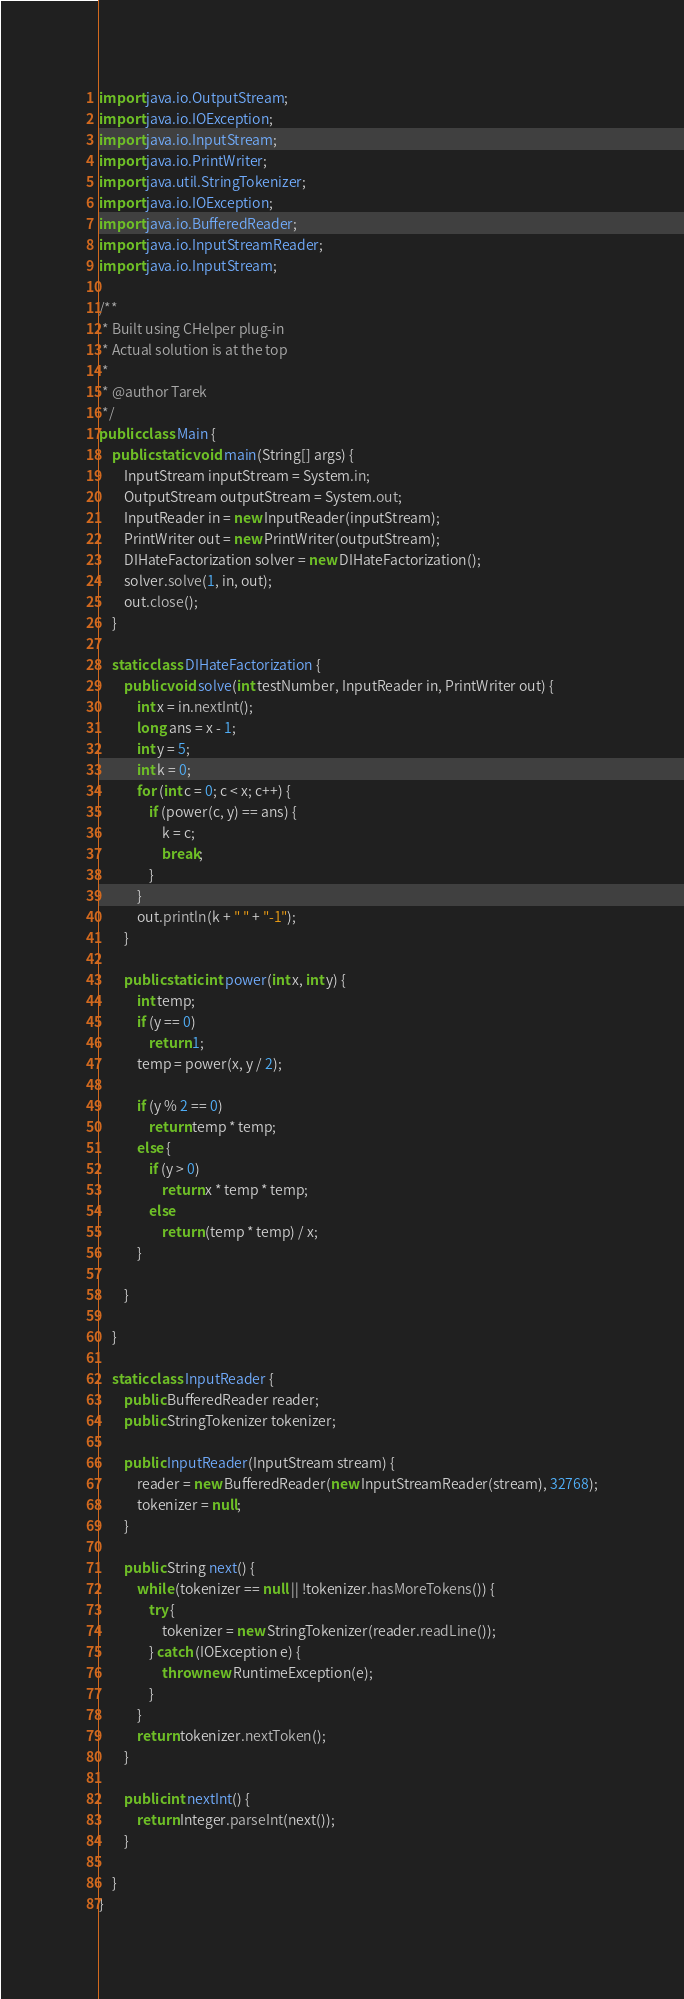<code> <loc_0><loc_0><loc_500><loc_500><_Java_>import java.io.OutputStream;
import java.io.IOException;
import java.io.InputStream;
import java.io.PrintWriter;
import java.util.StringTokenizer;
import java.io.IOException;
import java.io.BufferedReader;
import java.io.InputStreamReader;
import java.io.InputStream;

/**
 * Built using CHelper plug-in
 * Actual solution is at the top
 *
 * @author Tarek
 */
public class Main {
    public static void main(String[] args) {
        InputStream inputStream = System.in;
        OutputStream outputStream = System.out;
        InputReader in = new InputReader(inputStream);
        PrintWriter out = new PrintWriter(outputStream);
        DIHateFactorization solver = new DIHateFactorization();
        solver.solve(1, in, out);
        out.close();
    }

    static class DIHateFactorization {
        public void solve(int testNumber, InputReader in, PrintWriter out) {
            int x = in.nextInt();
            long ans = x - 1;
            int y = 5;
            int k = 0;
            for (int c = 0; c < x; c++) {
                if (power(c, y) == ans) {
                    k = c;
                    break;
                }
            }
            out.println(k + " " + "-1");
        }

        public static int power(int x, int y) {
            int temp;
            if (y == 0)
                return 1;
            temp = power(x, y / 2);

            if (y % 2 == 0)
                return temp * temp;
            else {
                if (y > 0)
                    return x * temp * temp;
                else
                    return (temp * temp) / x;
            }

        }

    }

    static class InputReader {
        public BufferedReader reader;
        public StringTokenizer tokenizer;

        public InputReader(InputStream stream) {
            reader = new BufferedReader(new InputStreamReader(stream), 32768);
            tokenizer = null;
        }

        public String next() {
            while (tokenizer == null || !tokenizer.hasMoreTokens()) {
                try {
                    tokenizer = new StringTokenizer(reader.readLine());
                } catch (IOException e) {
                    throw new RuntimeException(e);
                }
            }
            return tokenizer.nextToken();
        }

        public int nextInt() {
            return Integer.parseInt(next());
        }

    }
}

</code> 